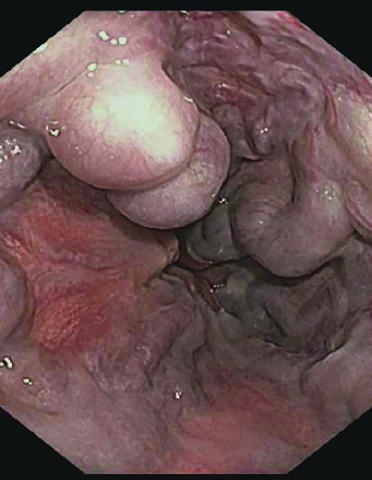s a uncleolar pattern more commonly used to identify varices?
Answer the question using a single word or phrase. No 